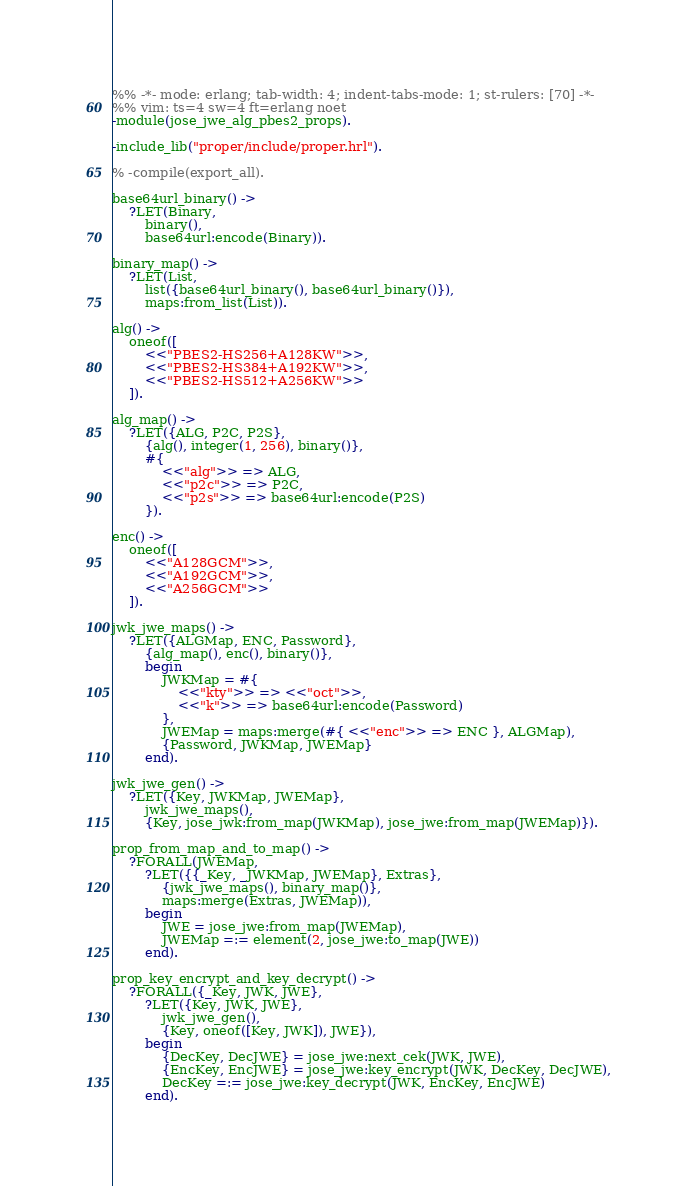Convert code to text. <code><loc_0><loc_0><loc_500><loc_500><_Erlang_>%% -*- mode: erlang; tab-width: 4; indent-tabs-mode: 1; st-rulers: [70] -*-
%% vim: ts=4 sw=4 ft=erlang noet
-module(jose_jwe_alg_pbes2_props).

-include_lib("proper/include/proper.hrl").

% -compile(export_all).

base64url_binary() ->
	?LET(Binary,
		binary(),
		base64url:encode(Binary)).

binary_map() ->
	?LET(List,
		list({base64url_binary(), base64url_binary()}),
		maps:from_list(List)).

alg() ->
	oneof([
		<<"PBES2-HS256+A128KW">>,
		<<"PBES2-HS384+A192KW">>,
		<<"PBES2-HS512+A256KW">>
	]).

alg_map() ->
	?LET({ALG, P2C, P2S},
		{alg(), integer(1, 256), binary()},
		#{
			<<"alg">> => ALG,
			<<"p2c">> => P2C,
			<<"p2s">> => base64url:encode(P2S)
		}).

enc() ->
	oneof([
		<<"A128GCM">>,
		<<"A192GCM">>,
		<<"A256GCM">>
	]).

jwk_jwe_maps() ->
	?LET({ALGMap, ENC, Password},
		{alg_map(), enc(), binary()},
		begin
			JWKMap = #{
				<<"kty">> => <<"oct">>,
				<<"k">> => base64url:encode(Password)
			},
			JWEMap = maps:merge(#{ <<"enc">> => ENC }, ALGMap),
			{Password, JWKMap, JWEMap}
		end).

jwk_jwe_gen() ->
	?LET({Key, JWKMap, JWEMap},
		jwk_jwe_maps(),
		{Key, jose_jwk:from_map(JWKMap), jose_jwe:from_map(JWEMap)}).

prop_from_map_and_to_map() ->
	?FORALL(JWEMap,
		?LET({{_Key, _JWKMap, JWEMap}, Extras},
			{jwk_jwe_maps(), binary_map()},
			maps:merge(Extras, JWEMap)),
		begin
			JWE = jose_jwe:from_map(JWEMap),
			JWEMap =:= element(2, jose_jwe:to_map(JWE))
		end).

prop_key_encrypt_and_key_decrypt() ->
	?FORALL({_Key, JWK, JWE},
		?LET({Key, JWK, JWE},
			jwk_jwe_gen(),
			{Key, oneof([Key, JWK]), JWE}),
		begin
			{DecKey, DecJWE} = jose_jwe:next_cek(JWK, JWE),
			{EncKey, EncJWE} = jose_jwe:key_encrypt(JWK, DecKey, DecJWE),
			DecKey =:= jose_jwe:key_decrypt(JWK, EncKey, EncJWE)
		end).
</code> 